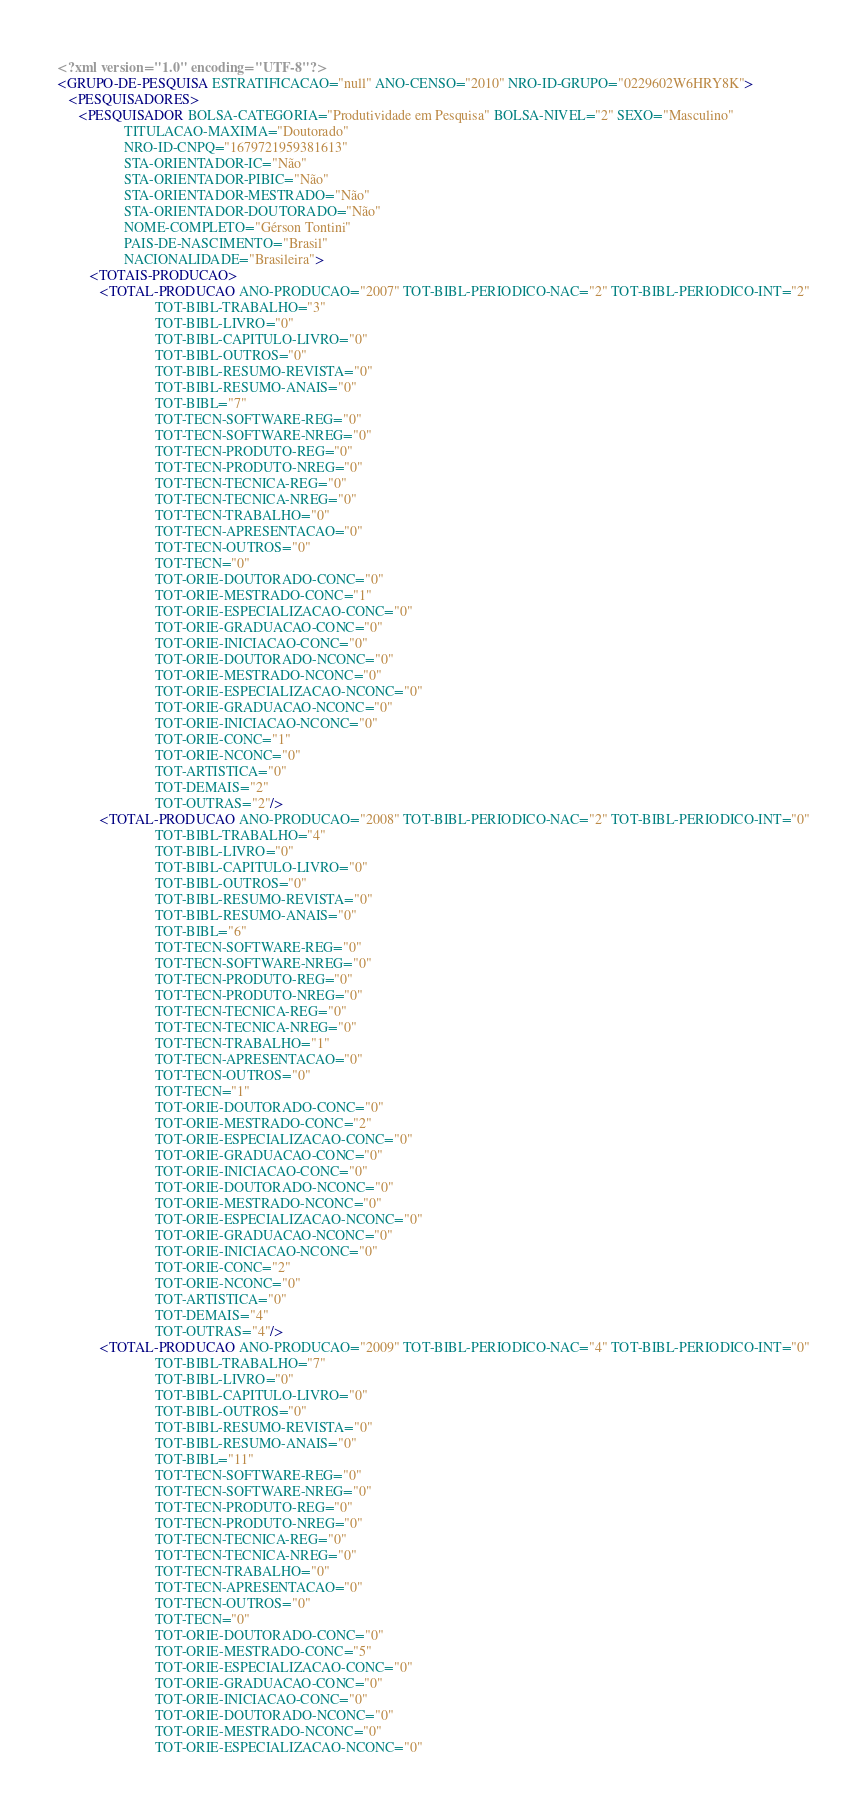Convert code to text. <code><loc_0><loc_0><loc_500><loc_500><_XML_><?xml version="1.0" encoding="UTF-8"?>
<GRUPO-DE-PESQUISA ESTRATIFICACAO="null" ANO-CENSO="2010" NRO-ID-GRUPO="0229602W6HRY8K">
   <PESQUISADORES>
      <PESQUISADOR BOLSA-CATEGORIA="Produtividade em Pesquisa" BOLSA-NIVEL="2" SEXO="Masculino"
                   TITULACAO-MAXIMA="Doutorado"
                   NRO-ID-CNPQ="1679721959381613"
                   STA-ORIENTADOR-IC="Não"
                   STA-ORIENTADOR-PIBIC="Não"
                   STA-ORIENTADOR-MESTRADO="Não"
                   STA-ORIENTADOR-DOUTORADO="Não"
                   NOME-COMPLETO="Gérson Tontini"
                   PAIS-DE-NASCIMENTO="Brasil"
                   NACIONALIDADE="Brasileira">
         <TOTAIS-PRODUCAO>
            <TOTAL-PRODUCAO ANO-PRODUCAO="2007" TOT-BIBL-PERIODICO-NAC="2" TOT-BIBL-PERIODICO-INT="2"
                            TOT-BIBL-TRABALHO="3"
                            TOT-BIBL-LIVRO="0"
                            TOT-BIBL-CAPITULO-LIVRO="0"
                            TOT-BIBL-OUTROS="0"
                            TOT-BIBL-RESUMO-REVISTA="0"
                            TOT-BIBL-RESUMO-ANAIS="0"
                            TOT-BIBL="7"
                            TOT-TECN-SOFTWARE-REG="0"
                            TOT-TECN-SOFTWARE-NREG="0"
                            TOT-TECN-PRODUTO-REG="0"
                            TOT-TECN-PRODUTO-NREG="0"
                            TOT-TECN-TECNICA-REG="0"
                            TOT-TECN-TECNICA-NREG="0"
                            TOT-TECN-TRABALHO="0"
                            TOT-TECN-APRESENTACAO="0"
                            TOT-TECN-OUTROS="0"
                            TOT-TECN="0"
                            TOT-ORIE-DOUTORADO-CONC="0"
                            TOT-ORIE-MESTRADO-CONC="1"
                            TOT-ORIE-ESPECIALIZACAO-CONC="0"
                            TOT-ORIE-GRADUACAO-CONC="0"
                            TOT-ORIE-INICIACAO-CONC="0"
                            TOT-ORIE-DOUTORADO-NCONC="0"
                            TOT-ORIE-MESTRADO-NCONC="0"
                            TOT-ORIE-ESPECIALIZACAO-NCONC="0"
                            TOT-ORIE-GRADUACAO-NCONC="0"
                            TOT-ORIE-INICIACAO-NCONC="0"
                            TOT-ORIE-CONC="1"
                            TOT-ORIE-NCONC="0"
                            TOT-ARTISTICA="0"
                            TOT-DEMAIS="2"
                            TOT-OUTRAS="2"/>
            <TOTAL-PRODUCAO ANO-PRODUCAO="2008" TOT-BIBL-PERIODICO-NAC="2" TOT-BIBL-PERIODICO-INT="0"
                            TOT-BIBL-TRABALHO="4"
                            TOT-BIBL-LIVRO="0"
                            TOT-BIBL-CAPITULO-LIVRO="0"
                            TOT-BIBL-OUTROS="0"
                            TOT-BIBL-RESUMO-REVISTA="0"
                            TOT-BIBL-RESUMO-ANAIS="0"
                            TOT-BIBL="6"
                            TOT-TECN-SOFTWARE-REG="0"
                            TOT-TECN-SOFTWARE-NREG="0"
                            TOT-TECN-PRODUTO-REG="0"
                            TOT-TECN-PRODUTO-NREG="0"
                            TOT-TECN-TECNICA-REG="0"
                            TOT-TECN-TECNICA-NREG="0"
                            TOT-TECN-TRABALHO="1"
                            TOT-TECN-APRESENTACAO="0"
                            TOT-TECN-OUTROS="0"
                            TOT-TECN="1"
                            TOT-ORIE-DOUTORADO-CONC="0"
                            TOT-ORIE-MESTRADO-CONC="2"
                            TOT-ORIE-ESPECIALIZACAO-CONC="0"
                            TOT-ORIE-GRADUACAO-CONC="0"
                            TOT-ORIE-INICIACAO-CONC="0"
                            TOT-ORIE-DOUTORADO-NCONC="0"
                            TOT-ORIE-MESTRADO-NCONC="0"
                            TOT-ORIE-ESPECIALIZACAO-NCONC="0"
                            TOT-ORIE-GRADUACAO-NCONC="0"
                            TOT-ORIE-INICIACAO-NCONC="0"
                            TOT-ORIE-CONC="2"
                            TOT-ORIE-NCONC="0"
                            TOT-ARTISTICA="0"
                            TOT-DEMAIS="4"
                            TOT-OUTRAS="4"/>
            <TOTAL-PRODUCAO ANO-PRODUCAO="2009" TOT-BIBL-PERIODICO-NAC="4" TOT-BIBL-PERIODICO-INT="0"
                            TOT-BIBL-TRABALHO="7"
                            TOT-BIBL-LIVRO="0"
                            TOT-BIBL-CAPITULO-LIVRO="0"
                            TOT-BIBL-OUTROS="0"
                            TOT-BIBL-RESUMO-REVISTA="0"
                            TOT-BIBL-RESUMO-ANAIS="0"
                            TOT-BIBL="11"
                            TOT-TECN-SOFTWARE-REG="0"
                            TOT-TECN-SOFTWARE-NREG="0"
                            TOT-TECN-PRODUTO-REG="0"
                            TOT-TECN-PRODUTO-NREG="0"
                            TOT-TECN-TECNICA-REG="0"
                            TOT-TECN-TECNICA-NREG="0"
                            TOT-TECN-TRABALHO="0"
                            TOT-TECN-APRESENTACAO="0"
                            TOT-TECN-OUTROS="0"
                            TOT-TECN="0"
                            TOT-ORIE-DOUTORADO-CONC="0"
                            TOT-ORIE-MESTRADO-CONC="5"
                            TOT-ORIE-ESPECIALIZACAO-CONC="0"
                            TOT-ORIE-GRADUACAO-CONC="0"
                            TOT-ORIE-INICIACAO-CONC="0"
                            TOT-ORIE-DOUTORADO-NCONC="0"
                            TOT-ORIE-MESTRADO-NCONC="0"
                            TOT-ORIE-ESPECIALIZACAO-NCONC="0"</code> 